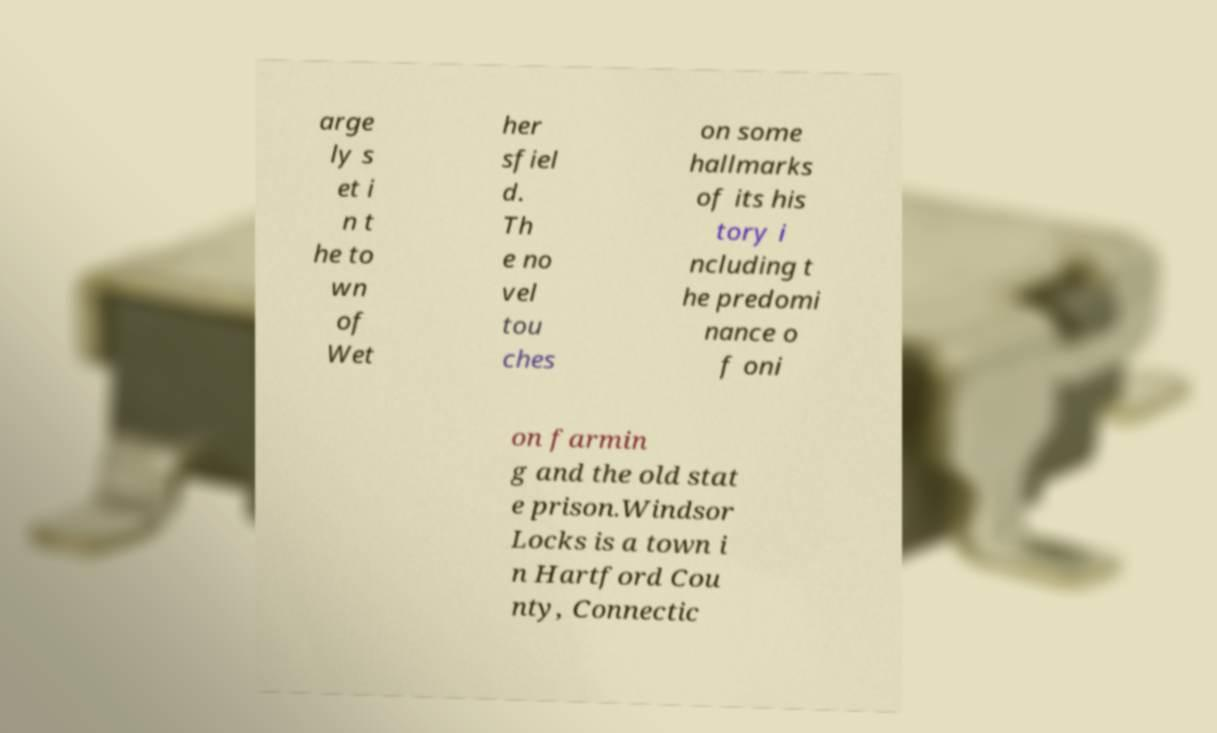Please identify and transcribe the text found in this image. arge ly s et i n t he to wn of Wet her sfiel d. Th e no vel tou ches on some hallmarks of its his tory i ncluding t he predomi nance o f oni on farmin g and the old stat e prison.Windsor Locks is a town i n Hartford Cou nty, Connectic 